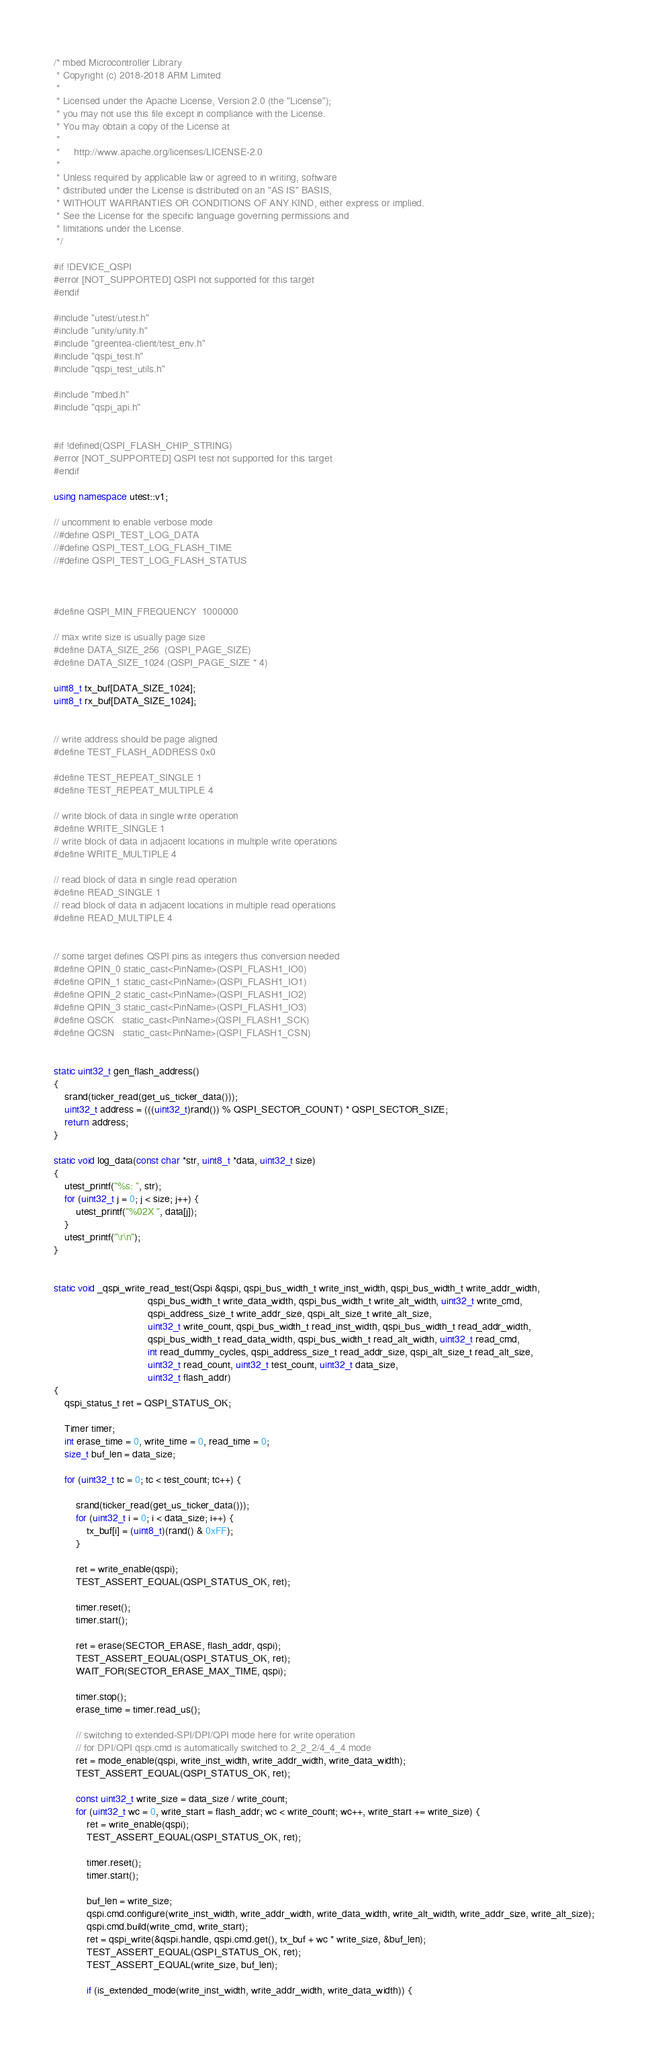<code> <loc_0><loc_0><loc_500><loc_500><_C++_>/* mbed Microcontroller Library
 * Copyright (c) 2018-2018 ARM Limited
 *
 * Licensed under the Apache License, Version 2.0 (the "License");
 * you may not use this file except in compliance with the License.
 * You may obtain a copy of the License at
 *
 *     http://www.apache.org/licenses/LICENSE-2.0
 *
 * Unless required by applicable law or agreed to in writing, software
 * distributed under the License is distributed on an "AS IS" BASIS,
 * WITHOUT WARRANTIES OR CONDITIONS OF ANY KIND, either express or implied.
 * See the License for the specific language governing permissions and
 * limitations under the License.
 */

#if !DEVICE_QSPI
#error [NOT_SUPPORTED] QSPI not supported for this target
#endif

#include "utest/utest.h"
#include "unity/unity.h"
#include "greentea-client/test_env.h"
#include "qspi_test.h"
#include "qspi_test_utils.h"

#include "mbed.h"
#include "qspi_api.h"


#if !defined(QSPI_FLASH_CHIP_STRING)
#error [NOT_SUPPORTED] QSPI test not supported for this target
#endif

using namespace utest::v1;

// uncomment to enable verbose mode
//#define QSPI_TEST_LOG_DATA
//#define QSPI_TEST_LOG_FLASH_TIME
//#define QSPI_TEST_LOG_FLASH_STATUS



#define QSPI_MIN_FREQUENCY  1000000

// max write size is usually page size
#define DATA_SIZE_256  (QSPI_PAGE_SIZE)
#define DATA_SIZE_1024 (QSPI_PAGE_SIZE * 4)

uint8_t tx_buf[DATA_SIZE_1024];
uint8_t rx_buf[DATA_SIZE_1024];


// write address should be page aligned
#define TEST_FLASH_ADDRESS 0x0

#define TEST_REPEAT_SINGLE 1
#define TEST_REPEAT_MULTIPLE 4

// write block of data in single write operation
#define WRITE_SINGLE 1
// write block of data in adjacent locations in multiple write operations
#define WRITE_MULTIPLE 4

// read block of data in single read operation
#define READ_SINGLE 1
// read block of data in adjacent locations in multiple read operations
#define READ_MULTIPLE 4


// some target defines QSPI pins as integers thus conversion needed
#define QPIN_0 static_cast<PinName>(QSPI_FLASH1_IO0)
#define QPIN_1 static_cast<PinName>(QSPI_FLASH1_IO1)
#define QPIN_2 static_cast<PinName>(QSPI_FLASH1_IO2)
#define QPIN_3 static_cast<PinName>(QSPI_FLASH1_IO3)
#define QSCK   static_cast<PinName>(QSPI_FLASH1_SCK)
#define QCSN   static_cast<PinName>(QSPI_FLASH1_CSN)


static uint32_t gen_flash_address()
{
    srand(ticker_read(get_us_ticker_data()));
    uint32_t address = (((uint32_t)rand()) % QSPI_SECTOR_COUNT) * QSPI_SECTOR_SIZE;
    return address;
}

static void log_data(const char *str, uint8_t *data, uint32_t size)
{
    utest_printf("%s: ", str);
    for (uint32_t j = 0; j < size; j++) {
        utest_printf("%02X ", data[j]);
    }
    utest_printf("\r\n");
}


static void _qspi_write_read_test(Qspi &qspi, qspi_bus_width_t write_inst_width, qspi_bus_width_t write_addr_width,
                                  qspi_bus_width_t write_data_width, qspi_bus_width_t write_alt_width, uint32_t write_cmd,
                                  qspi_address_size_t write_addr_size, qspi_alt_size_t write_alt_size,
                                  uint32_t write_count, qspi_bus_width_t read_inst_width, qspi_bus_width_t read_addr_width,
                                  qspi_bus_width_t read_data_width, qspi_bus_width_t read_alt_width, uint32_t read_cmd,
                                  int read_dummy_cycles, qspi_address_size_t read_addr_size, qspi_alt_size_t read_alt_size,
                                  uint32_t read_count, uint32_t test_count, uint32_t data_size,
                                  uint32_t flash_addr)
{
    qspi_status_t ret = QSPI_STATUS_OK;

    Timer timer;
    int erase_time = 0, write_time = 0, read_time = 0;
    size_t buf_len = data_size;

    for (uint32_t tc = 0; tc < test_count; tc++) {

        srand(ticker_read(get_us_ticker_data()));
        for (uint32_t i = 0; i < data_size; i++) {
            tx_buf[i] = (uint8_t)(rand() & 0xFF);
        }

        ret = write_enable(qspi);
        TEST_ASSERT_EQUAL(QSPI_STATUS_OK, ret);

        timer.reset();
        timer.start();

        ret = erase(SECTOR_ERASE, flash_addr, qspi);
        TEST_ASSERT_EQUAL(QSPI_STATUS_OK, ret);
        WAIT_FOR(SECTOR_ERASE_MAX_TIME, qspi);

        timer.stop();
        erase_time = timer.read_us();

        // switching to extended-SPI/DPI/QPI mode here for write operation
        // for DPI/QPI qspi.cmd is automatically switched to 2_2_2/4_4_4 mode
        ret = mode_enable(qspi, write_inst_width, write_addr_width, write_data_width);
        TEST_ASSERT_EQUAL(QSPI_STATUS_OK, ret);

        const uint32_t write_size = data_size / write_count;
        for (uint32_t wc = 0, write_start = flash_addr; wc < write_count; wc++, write_start += write_size) {
            ret = write_enable(qspi);
            TEST_ASSERT_EQUAL(QSPI_STATUS_OK, ret);

            timer.reset();
            timer.start();

            buf_len = write_size;
            qspi.cmd.configure(write_inst_width, write_addr_width, write_data_width, write_alt_width, write_addr_size, write_alt_size);
            qspi.cmd.build(write_cmd, write_start);
            ret = qspi_write(&qspi.handle, qspi.cmd.get(), tx_buf + wc * write_size, &buf_len);
            TEST_ASSERT_EQUAL(QSPI_STATUS_OK, ret);
            TEST_ASSERT_EQUAL(write_size, buf_len);

            if (is_extended_mode(write_inst_width, write_addr_width, write_data_width)) {</code> 